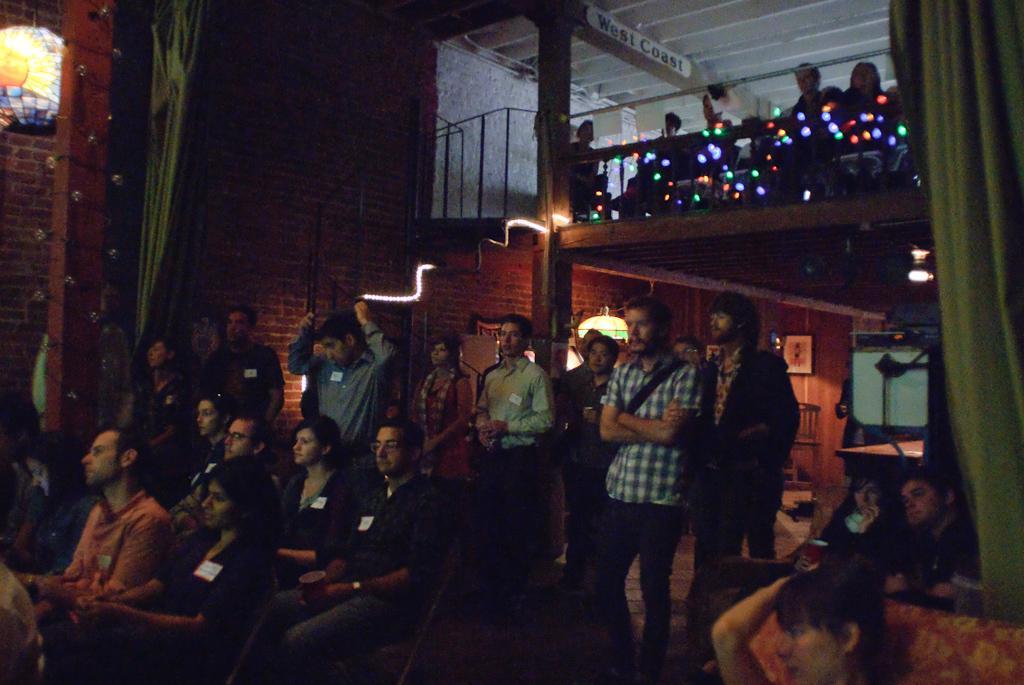Can you describe this image briefly? This image is taken from inside. In this image there are a few people sitting and standing, there are curtains and a decoration on the pillar and railing, behind the railing there are a few people sitting. In the background there is a frame hanging on the wall. 